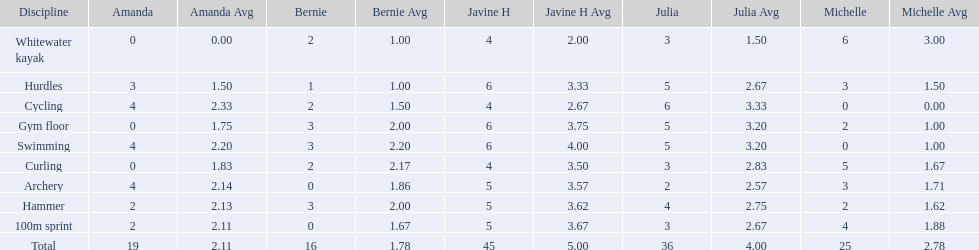Who had the least points in the whitewater kayak event? Amanda. Parse the table in full. {'header': ['Discipline', 'Amanda', 'Amanda Avg', 'Bernie', 'Bernie Avg', 'Javine H', 'Javine H Avg', 'Julia', 'Julia Avg', 'Michelle', 'Michelle Avg'], 'rows': [['Whitewater kayak', '0', '0.00', '2', '1.00', '4', '2.00', '3', '1.50', '6', '3.00'], ['Hurdles', '3', '1.50', '1', '1.00', '6', '3.33', '5', '2.67', '3', '1.50'], ['Cycling', '4', '2.33', '2', '1.50', '4', '2.67', '6', '3.33', '0', '0.00'], ['Gym floor', '0', '1.75', '3', '2.00', '6', '3.75', '5', '3.20', '2', '1.00'], ['Swimming', '4', '2.20', '3', '2.20', '6', '4.00', '5', '3.20', '0', '1.00'], ['Curling', '0', '1.83', '2', '2.17', '4', '3.50', '3', '2.83', '5', '1.67'], ['Archery', '4', '2.14', '0', '1.86', '5', '3.57', '2', '2.57', '3', '1.71'], ['Hammer', '2', '2.13', '3', '2.00', '5', '3.62', '4', '2.75', '2', '1.62'], ['100m sprint', '2', '2.11', '0', '1.67', '5', '3.67', '3', '2.67', '4', '1.88'], ['Total', '19', '2.11', '16', '1.78', '45', '5.00', '36', '4.00', '25', '2.78']]} 